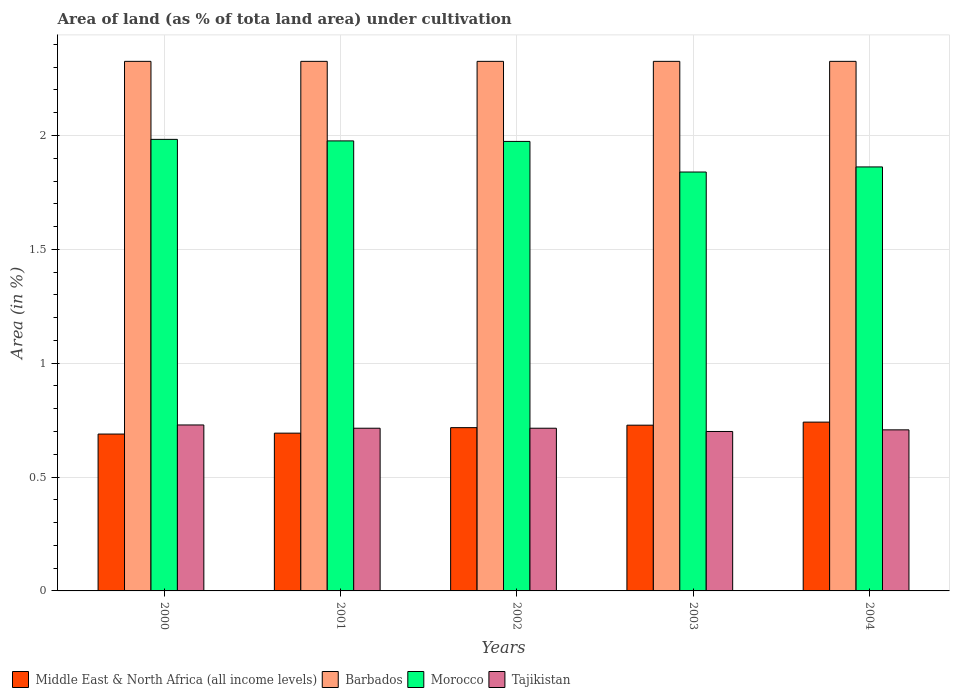Are the number of bars on each tick of the X-axis equal?
Ensure brevity in your answer.  Yes. How many bars are there on the 5th tick from the right?
Your answer should be compact. 4. What is the label of the 4th group of bars from the left?
Provide a succinct answer. 2003. What is the percentage of land under cultivation in Tajikistan in 2001?
Make the answer very short. 0.71. Across all years, what is the maximum percentage of land under cultivation in Morocco?
Make the answer very short. 1.98. Across all years, what is the minimum percentage of land under cultivation in Tajikistan?
Keep it short and to the point. 0.7. In which year was the percentage of land under cultivation in Middle East & North Africa (all income levels) minimum?
Provide a short and direct response. 2000. What is the total percentage of land under cultivation in Barbados in the graph?
Ensure brevity in your answer.  11.63. What is the difference between the percentage of land under cultivation in Tajikistan in 2001 and the percentage of land under cultivation in Barbados in 2002?
Your response must be concise. -1.61. What is the average percentage of land under cultivation in Middle East & North Africa (all income levels) per year?
Provide a succinct answer. 0.71. In the year 2000, what is the difference between the percentage of land under cultivation in Morocco and percentage of land under cultivation in Barbados?
Your answer should be compact. -0.34. What is the difference between the highest and the second highest percentage of land under cultivation in Tajikistan?
Offer a terse response. 0.01. What is the difference between the highest and the lowest percentage of land under cultivation in Morocco?
Your answer should be very brief. 0.14. Is the sum of the percentage of land under cultivation in Morocco in 2001 and 2002 greater than the maximum percentage of land under cultivation in Middle East & North Africa (all income levels) across all years?
Provide a succinct answer. Yes. Is it the case that in every year, the sum of the percentage of land under cultivation in Tajikistan and percentage of land under cultivation in Middle East & North Africa (all income levels) is greater than the sum of percentage of land under cultivation in Barbados and percentage of land under cultivation in Morocco?
Provide a succinct answer. No. What does the 3rd bar from the left in 2000 represents?
Your answer should be very brief. Morocco. What does the 4th bar from the right in 2000 represents?
Offer a very short reply. Middle East & North Africa (all income levels). Is it the case that in every year, the sum of the percentage of land under cultivation in Tajikistan and percentage of land under cultivation in Barbados is greater than the percentage of land under cultivation in Morocco?
Offer a very short reply. Yes. What is the difference between two consecutive major ticks on the Y-axis?
Your answer should be very brief. 0.5. Are the values on the major ticks of Y-axis written in scientific E-notation?
Provide a short and direct response. No. Where does the legend appear in the graph?
Provide a short and direct response. Bottom left. How many legend labels are there?
Provide a succinct answer. 4. What is the title of the graph?
Offer a terse response. Area of land (as % of tota land area) under cultivation. What is the label or title of the X-axis?
Your response must be concise. Years. What is the label or title of the Y-axis?
Keep it short and to the point. Area (in %). What is the Area (in %) of Middle East & North Africa (all income levels) in 2000?
Give a very brief answer. 0.69. What is the Area (in %) of Barbados in 2000?
Your answer should be very brief. 2.33. What is the Area (in %) in Morocco in 2000?
Offer a very short reply. 1.98. What is the Area (in %) of Tajikistan in 2000?
Your response must be concise. 0.73. What is the Area (in %) of Middle East & North Africa (all income levels) in 2001?
Provide a short and direct response. 0.69. What is the Area (in %) in Barbados in 2001?
Ensure brevity in your answer.  2.33. What is the Area (in %) in Morocco in 2001?
Your answer should be very brief. 1.98. What is the Area (in %) in Tajikistan in 2001?
Keep it short and to the point. 0.71. What is the Area (in %) of Middle East & North Africa (all income levels) in 2002?
Your response must be concise. 0.72. What is the Area (in %) of Barbados in 2002?
Provide a succinct answer. 2.33. What is the Area (in %) of Morocco in 2002?
Provide a succinct answer. 1.97. What is the Area (in %) in Tajikistan in 2002?
Offer a very short reply. 0.71. What is the Area (in %) in Middle East & North Africa (all income levels) in 2003?
Offer a terse response. 0.73. What is the Area (in %) in Barbados in 2003?
Your response must be concise. 2.33. What is the Area (in %) in Morocco in 2003?
Ensure brevity in your answer.  1.84. What is the Area (in %) of Tajikistan in 2003?
Keep it short and to the point. 0.7. What is the Area (in %) of Middle East & North Africa (all income levels) in 2004?
Your response must be concise. 0.74. What is the Area (in %) of Barbados in 2004?
Provide a short and direct response. 2.33. What is the Area (in %) in Morocco in 2004?
Keep it short and to the point. 1.86. What is the Area (in %) in Tajikistan in 2004?
Ensure brevity in your answer.  0.71. Across all years, what is the maximum Area (in %) in Middle East & North Africa (all income levels)?
Provide a succinct answer. 0.74. Across all years, what is the maximum Area (in %) of Barbados?
Give a very brief answer. 2.33. Across all years, what is the maximum Area (in %) of Morocco?
Your answer should be compact. 1.98. Across all years, what is the maximum Area (in %) in Tajikistan?
Ensure brevity in your answer.  0.73. Across all years, what is the minimum Area (in %) in Middle East & North Africa (all income levels)?
Ensure brevity in your answer.  0.69. Across all years, what is the minimum Area (in %) in Barbados?
Give a very brief answer. 2.33. Across all years, what is the minimum Area (in %) in Morocco?
Provide a succinct answer. 1.84. Across all years, what is the minimum Area (in %) in Tajikistan?
Offer a very short reply. 0.7. What is the total Area (in %) in Middle East & North Africa (all income levels) in the graph?
Provide a succinct answer. 3.57. What is the total Area (in %) of Barbados in the graph?
Keep it short and to the point. 11.63. What is the total Area (in %) of Morocco in the graph?
Ensure brevity in your answer.  9.63. What is the total Area (in %) of Tajikistan in the graph?
Ensure brevity in your answer.  3.57. What is the difference between the Area (in %) in Middle East & North Africa (all income levels) in 2000 and that in 2001?
Your answer should be compact. -0. What is the difference between the Area (in %) of Barbados in 2000 and that in 2001?
Your answer should be compact. 0. What is the difference between the Area (in %) of Morocco in 2000 and that in 2001?
Offer a very short reply. 0.01. What is the difference between the Area (in %) in Tajikistan in 2000 and that in 2001?
Offer a very short reply. 0.01. What is the difference between the Area (in %) of Middle East & North Africa (all income levels) in 2000 and that in 2002?
Ensure brevity in your answer.  -0.03. What is the difference between the Area (in %) in Barbados in 2000 and that in 2002?
Your answer should be compact. 0. What is the difference between the Area (in %) in Morocco in 2000 and that in 2002?
Provide a short and direct response. 0.01. What is the difference between the Area (in %) of Tajikistan in 2000 and that in 2002?
Offer a very short reply. 0.01. What is the difference between the Area (in %) in Middle East & North Africa (all income levels) in 2000 and that in 2003?
Provide a short and direct response. -0.04. What is the difference between the Area (in %) of Barbados in 2000 and that in 2003?
Keep it short and to the point. 0. What is the difference between the Area (in %) of Morocco in 2000 and that in 2003?
Provide a short and direct response. 0.14. What is the difference between the Area (in %) of Tajikistan in 2000 and that in 2003?
Your response must be concise. 0.03. What is the difference between the Area (in %) of Middle East & North Africa (all income levels) in 2000 and that in 2004?
Your response must be concise. -0.05. What is the difference between the Area (in %) of Morocco in 2000 and that in 2004?
Your response must be concise. 0.12. What is the difference between the Area (in %) of Tajikistan in 2000 and that in 2004?
Your answer should be compact. 0.02. What is the difference between the Area (in %) of Middle East & North Africa (all income levels) in 2001 and that in 2002?
Provide a short and direct response. -0.02. What is the difference between the Area (in %) in Morocco in 2001 and that in 2002?
Keep it short and to the point. 0. What is the difference between the Area (in %) of Middle East & North Africa (all income levels) in 2001 and that in 2003?
Make the answer very short. -0.04. What is the difference between the Area (in %) of Barbados in 2001 and that in 2003?
Offer a terse response. 0. What is the difference between the Area (in %) of Morocco in 2001 and that in 2003?
Your response must be concise. 0.14. What is the difference between the Area (in %) of Tajikistan in 2001 and that in 2003?
Offer a very short reply. 0.01. What is the difference between the Area (in %) of Middle East & North Africa (all income levels) in 2001 and that in 2004?
Make the answer very short. -0.05. What is the difference between the Area (in %) in Barbados in 2001 and that in 2004?
Provide a succinct answer. 0. What is the difference between the Area (in %) in Morocco in 2001 and that in 2004?
Provide a short and direct response. 0.11. What is the difference between the Area (in %) of Tajikistan in 2001 and that in 2004?
Ensure brevity in your answer.  0.01. What is the difference between the Area (in %) in Middle East & North Africa (all income levels) in 2002 and that in 2003?
Ensure brevity in your answer.  -0.01. What is the difference between the Area (in %) of Morocco in 2002 and that in 2003?
Provide a succinct answer. 0.13. What is the difference between the Area (in %) in Tajikistan in 2002 and that in 2003?
Provide a short and direct response. 0.01. What is the difference between the Area (in %) in Middle East & North Africa (all income levels) in 2002 and that in 2004?
Provide a succinct answer. -0.02. What is the difference between the Area (in %) in Morocco in 2002 and that in 2004?
Your answer should be very brief. 0.11. What is the difference between the Area (in %) in Tajikistan in 2002 and that in 2004?
Keep it short and to the point. 0.01. What is the difference between the Area (in %) in Middle East & North Africa (all income levels) in 2003 and that in 2004?
Provide a succinct answer. -0.01. What is the difference between the Area (in %) of Morocco in 2003 and that in 2004?
Your answer should be compact. -0.02. What is the difference between the Area (in %) of Tajikistan in 2003 and that in 2004?
Keep it short and to the point. -0.01. What is the difference between the Area (in %) in Middle East & North Africa (all income levels) in 2000 and the Area (in %) in Barbados in 2001?
Offer a very short reply. -1.64. What is the difference between the Area (in %) of Middle East & North Africa (all income levels) in 2000 and the Area (in %) of Morocco in 2001?
Provide a short and direct response. -1.29. What is the difference between the Area (in %) in Middle East & North Africa (all income levels) in 2000 and the Area (in %) in Tajikistan in 2001?
Offer a terse response. -0.03. What is the difference between the Area (in %) of Barbados in 2000 and the Area (in %) of Morocco in 2001?
Your response must be concise. 0.35. What is the difference between the Area (in %) in Barbados in 2000 and the Area (in %) in Tajikistan in 2001?
Your answer should be compact. 1.61. What is the difference between the Area (in %) of Morocco in 2000 and the Area (in %) of Tajikistan in 2001?
Offer a very short reply. 1.27. What is the difference between the Area (in %) in Middle East & North Africa (all income levels) in 2000 and the Area (in %) in Barbados in 2002?
Ensure brevity in your answer.  -1.64. What is the difference between the Area (in %) of Middle East & North Africa (all income levels) in 2000 and the Area (in %) of Morocco in 2002?
Give a very brief answer. -1.29. What is the difference between the Area (in %) in Middle East & North Africa (all income levels) in 2000 and the Area (in %) in Tajikistan in 2002?
Provide a succinct answer. -0.03. What is the difference between the Area (in %) of Barbados in 2000 and the Area (in %) of Morocco in 2002?
Offer a very short reply. 0.35. What is the difference between the Area (in %) of Barbados in 2000 and the Area (in %) of Tajikistan in 2002?
Make the answer very short. 1.61. What is the difference between the Area (in %) of Morocco in 2000 and the Area (in %) of Tajikistan in 2002?
Provide a short and direct response. 1.27. What is the difference between the Area (in %) in Middle East & North Africa (all income levels) in 2000 and the Area (in %) in Barbados in 2003?
Ensure brevity in your answer.  -1.64. What is the difference between the Area (in %) in Middle East & North Africa (all income levels) in 2000 and the Area (in %) in Morocco in 2003?
Provide a succinct answer. -1.15. What is the difference between the Area (in %) in Middle East & North Africa (all income levels) in 2000 and the Area (in %) in Tajikistan in 2003?
Provide a succinct answer. -0.01. What is the difference between the Area (in %) of Barbados in 2000 and the Area (in %) of Morocco in 2003?
Provide a short and direct response. 0.49. What is the difference between the Area (in %) in Barbados in 2000 and the Area (in %) in Tajikistan in 2003?
Make the answer very short. 1.63. What is the difference between the Area (in %) in Morocco in 2000 and the Area (in %) in Tajikistan in 2003?
Provide a short and direct response. 1.28. What is the difference between the Area (in %) in Middle East & North Africa (all income levels) in 2000 and the Area (in %) in Barbados in 2004?
Make the answer very short. -1.64. What is the difference between the Area (in %) in Middle East & North Africa (all income levels) in 2000 and the Area (in %) in Morocco in 2004?
Your answer should be compact. -1.17. What is the difference between the Area (in %) in Middle East & North Africa (all income levels) in 2000 and the Area (in %) in Tajikistan in 2004?
Provide a succinct answer. -0.02. What is the difference between the Area (in %) in Barbados in 2000 and the Area (in %) in Morocco in 2004?
Your answer should be compact. 0.46. What is the difference between the Area (in %) of Barbados in 2000 and the Area (in %) of Tajikistan in 2004?
Provide a succinct answer. 1.62. What is the difference between the Area (in %) of Morocco in 2000 and the Area (in %) of Tajikistan in 2004?
Your answer should be very brief. 1.28. What is the difference between the Area (in %) of Middle East & North Africa (all income levels) in 2001 and the Area (in %) of Barbados in 2002?
Provide a succinct answer. -1.63. What is the difference between the Area (in %) in Middle East & North Africa (all income levels) in 2001 and the Area (in %) in Morocco in 2002?
Offer a very short reply. -1.28. What is the difference between the Area (in %) in Middle East & North Africa (all income levels) in 2001 and the Area (in %) in Tajikistan in 2002?
Your answer should be compact. -0.02. What is the difference between the Area (in %) of Barbados in 2001 and the Area (in %) of Morocco in 2002?
Ensure brevity in your answer.  0.35. What is the difference between the Area (in %) in Barbados in 2001 and the Area (in %) in Tajikistan in 2002?
Provide a short and direct response. 1.61. What is the difference between the Area (in %) in Morocco in 2001 and the Area (in %) in Tajikistan in 2002?
Your response must be concise. 1.26. What is the difference between the Area (in %) of Middle East & North Africa (all income levels) in 2001 and the Area (in %) of Barbados in 2003?
Make the answer very short. -1.63. What is the difference between the Area (in %) of Middle East & North Africa (all income levels) in 2001 and the Area (in %) of Morocco in 2003?
Keep it short and to the point. -1.15. What is the difference between the Area (in %) in Middle East & North Africa (all income levels) in 2001 and the Area (in %) in Tajikistan in 2003?
Keep it short and to the point. -0.01. What is the difference between the Area (in %) in Barbados in 2001 and the Area (in %) in Morocco in 2003?
Keep it short and to the point. 0.49. What is the difference between the Area (in %) in Barbados in 2001 and the Area (in %) in Tajikistan in 2003?
Keep it short and to the point. 1.63. What is the difference between the Area (in %) of Morocco in 2001 and the Area (in %) of Tajikistan in 2003?
Provide a succinct answer. 1.28. What is the difference between the Area (in %) in Middle East & North Africa (all income levels) in 2001 and the Area (in %) in Barbados in 2004?
Make the answer very short. -1.63. What is the difference between the Area (in %) in Middle East & North Africa (all income levels) in 2001 and the Area (in %) in Morocco in 2004?
Offer a very short reply. -1.17. What is the difference between the Area (in %) in Middle East & North Africa (all income levels) in 2001 and the Area (in %) in Tajikistan in 2004?
Provide a succinct answer. -0.01. What is the difference between the Area (in %) in Barbados in 2001 and the Area (in %) in Morocco in 2004?
Ensure brevity in your answer.  0.46. What is the difference between the Area (in %) in Barbados in 2001 and the Area (in %) in Tajikistan in 2004?
Make the answer very short. 1.62. What is the difference between the Area (in %) of Morocco in 2001 and the Area (in %) of Tajikistan in 2004?
Ensure brevity in your answer.  1.27. What is the difference between the Area (in %) of Middle East & North Africa (all income levels) in 2002 and the Area (in %) of Barbados in 2003?
Ensure brevity in your answer.  -1.61. What is the difference between the Area (in %) of Middle East & North Africa (all income levels) in 2002 and the Area (in %) of Morocco in 2003?
Ensure brevity in your answer.  -1.12. What is the difference between the Area (in %) of Middle East & North Africa (all income levels) in 2002 and the Area (in %) of Tajikistan in 2003?
Give a very brief answer. 0.02. What is the difference between the Area (in %) of Barbados in 2002 and the Area (in %) of Morocco in 2003?
Keep it short and to the point. 0.49. What is the difference between the Area (in %) in Barbados in 2002 and the Area (in %) in Tajikistan in 2003?
Offer a terse response. 1.63. What is the difference between the Area (in %) of Morocco in 2002 and the Area (in %) of Tajikistan in 2003?
Your answer should be compact. 1.27. What is the difference between the Area (in %) of Middle East & North Africa (all income levels) in 2002 and the Area (in %) of Barbados in 2004?
Offer a very short reply. -1.61. What is the difference between the Area (in %) of Middle East & North Africa (all income levels) in 2002 and the Area (in %) of Morocco in 2004?
Your answer should be compact. -1.15. What is the difference between the Area (in %) in Middle East & North Africa (all income levels) in 2002 and the Area (in %) in Tajikistan in 2004?
Ensure brevity in your answer.  0.01. What is the difference between the Area (in %) in Barbados in 2002 and the Area (in %) in Morocco in 2004?
Provide a short and direct response. 0.46. What is the difference between the Area (in %) of Barbados in 2002 and the Area (in %) of Tajikistan in 2004?
Provide a succinct answer. 1.62. What is the difference between the Area (in %) in Morocco in 2002 and the Area (in %) in Tajikistan in 2004?
Your answer should be compact. 1.27. What is the difference between the Area (in %) in Middle East & North Africa (all income levels) in 2003 and the Area (in %) in Barbados in 2004?
Keep it short and to the point. -1.6. What is the difference between the Area (in %) in Middle East & North Africa (all income levels) in 2003 and the Area (in %) in Morocco in 2004?
Your response must be concise. -1.13. What is the difference between the Area (in %) in Middle East & North Africa (all income levels) in 2003 and the Area (in %) in Tajikistan in 2004?
Make the answer very short. 0.02. What is the difference between the Area (in %) of Barbados in 2003 and the Area (in %) of Morocco in 2004?
Make the answer very short. 0.46. What is the difference between the Area (in %) of Barbados in 2003 and the Area (in %) of Tajikistan in 2004?
Your response must be concise. 1.62. What is the difference between the Area (in %) in Morocco in 2003 and the Area (in %) in Tajikistan in 2004?
Keep it short and to the point. 1.13. What is the average Area (in %) in Middle East & North Africa (all income levels) per year?
Provide a short and direct response. 0.71. What is the average Area (in %) in Barbados per year?
Your answer should be compact. 2.33. What is the average Area (in %) in Morocco per year?
Ensure brevity in your answer.  1.93. What is the average Area (in %) of Tajikistan per year?
Provide a succinct answer. 0.71. In the year 2000, what is the difference between the Area (in %) in Middle East & North Africa (all income levels) and Area (in %) in Barbados?
Give a very brief answer. -1.64. In the year 2000, what is the difference between the Area (in %) of Middle East & North Africa (all income levels) and Area (in %) of Morocco?
Give a very brief answer. -1.29. In the year 2000, what is the difference between the Area (in %) in Middle East & North Africa (all income levels) and Area (in %) in Tajikistan?
Provide a succinct answer. -0.04. In the year 2000, what is the difference between the Area (in %) in Barbados and Area (in %) in Morocco?
Keep it short and to the point. 0.34. In the year 2000, what is the difference between the Area (in %) of Barbados and Area (in %) of Tajikistan?
Ensure brevity in your answer.  1.6. In the year 2000, what is the difference between the Area (in %) of Morocco and Area (in %) of Tajikistan?
Your response must be concise. 1.25. In the year 2001, what is the difference between the Area (in %) in Middle East & North Africa (all income levels) and Area (in %) in Barbados?
Ensure brevity in your answer.  -1.63. In the year 2001, what is the difference between the Area (in %) of Middle East & North Africa (all income levels) and Area (in %) of Morocco?
Your response must be concise. -1.28. In the year 2001, what is the difference between the Area (in %) of Middle East & North Africa (all income levels) and Area (in %) of Tajikistan?
Make the answer very short. -0.02. In the year 2001, what is the difference between the Area (in %) of Barbados and Area (in %) of Morocco?
Keep it short and to the point. 0.35. In the year 2001, what is the difference between the Area (in %) in Barbados and Area (in %) in Tajikistan?
Keep it short and to the point. 1.61. In the year 2001, what is the difference between the Area (in %) in Morocco and Area (in %) in Tajikistan?
Give a very brief answer. 1.26. In the year 2002, what is the difference between the Area (in %) of Middle East & North Africa (all income levels) and Area (in %) of Barbados?
Offer a very short reply. -1.61. In the year 2002, what is the difference between the Area (in %) of Middle East & North Africa (all income levels) and Area (in %) of Morocco?
Offer a very short reply. -1.26. In the year 2002, what is the difference between the Area (in %) in Middle East & North Africa (all income levels) and Area (in %) in Tajikistan?
Offer a terse response. 0. In the year 2002, what is the difference between the Area (in %) of Barbados and Area (in %) of Morocco?
Your answer should be compact. 0.35. In the year 2002, what is the difference between the Area (in %) of Barbados and Area (in %) of Tajikistan?
Provide a short and direct response. 1.61. In the year 2002, what is the difference between the Area (in %) of Morocco and Area (in %) of Tajikistan?
Your answer should be compact. 1.26. In the year 2003, what is the difference between the Area (in %) in Middle East & North Africa (all income levels) and Area (in %) in Barbados?
Offer a terse response. -1.6. In the year 2003, what is the difference between the Area (in %) in Middle East & North Africa (all income levels) and Area (in %) in Morocco?
Offer a very short reply. -1.11. In the year 2003, what is the difference between the Area (in %) of Middle East & North Africa (all income levels) and Area (in %) of Tajikistan?
Keep it short and to the point. 0.03. In the year 2003, what is the difference between the Area (in %) in Barbados and Area (in %) in Morocco?
Offer a terse response. 0.49. In the year 2003, what is the difference between the Area (in %) of Barbados and Area (in %) of Tajikistan?
Make the answer very short. 1.63. In the year 2003, what is the difference between the Area (in %) of Morocco and Area (in %) of Tajikistan?
Provide a short and direct response. 1.14. In the year 2004, what is the difference between the Area (in %) in Middle East & North Africa (all income levels) and Area (in %) in Barbados?
Give a very brief answer. -1.58. In the year 2004, what is the difference between the Area (in %) of Middle East & North Africa (all income levels) and Area (in %) of Morocco?
Provide a short and direct response. -1.12. In the year 2004, what is the difference between the Area (in %) in Middle East & North Africa (all income levels) and Area (in %) in Tajikistan?
Make the answer very short. 0.03. In the year 2004, what is the difference between the Area (in %) in Barbados and Area (in %) in Morocco?
Keep it short and to the point. 0.46. In the year 2004, what is the difference between the Area (in %) in Barbados and Area (in %) in Tajikistan?
Offer a terse response. 1.62. In the year 2004, what is the difference between the Area (in %) in Morocco and Area (in %) in Tajikistan?
Offer a very short reply. 1.15. What is the ratio of the Area (in %) in Middle East & North Africa (all income levels) in 2000 to that in 2001?
Keep it short and to the point. 0.99. What is the ratio of the Area (in %) in Barbados in 2000 to that in 2001?
Make the answer very short. 1. What is the ratio of the Area (in %) in Tajikistan in 2000 to that in 2001?
Offer a terse response. 1.02. What is the ratio of the Area (in %) of Middle East & North Africa (all income levels) in 2000 to that in 2002?
Provide a succinct answer. 0.96. What is the ratio of the Area (in %) in Tajikistan in 2000 to that in 2002?
Make the answer very short. 1.02. What is the ratio of the Area (in %) in Middle East & North Africa (all income levels) in 2000 to that in 2003?
Your answer should be very brief. 0.95. What is the ratio of the Area (in %) in Barbados in 2000 to that in 2003?
Offer a very short reply. 1. What is the ratio of the Area (in %) in Morocco in 2000 to that in 2003?
Your answer should be very brief. 1.08. What is the ratio of the Area (in %) of Tajikistan in 2000 to that in 2003?
Provide a succinct answer. 1.04. What is the ratio of the Area (in %) in Middle East & North Africa (all income levels) in 2000 to that in 2004?
Offer a very short reply. 0.93. What is the ratio of the Area (in %) in Morocco in 2000 to that in 2004?
Give a very brief answer. 1.06. What is the ratio of the Area (in %) of Tajikistan in 2000 to that in 2004?
Your response must be concise. 1.03. What is the ratio of the Area (in %) of Middle East & North Africa (all income levels) in 2001 to that in 2002?
Provide a succinct answer. 0.97. What is the ratio of the Area (in %) of Barbados in 2001 to that in 2002?
Your answer should be compact. 1. What is the ratio of the Area (in %) in Morocco in 2001 to that in 2002?
Ensure brevity in your answer.  1. What is the ratio of the Area (in %) of Middle East & North Africa (all income levels) in 2001 to that in 2003?
Your answer should be very brief. 0.95. What is the ratio of the Area (in %) of Barbados in 2001 to that in 2003?
Provide a succinct answer. 1. What is the ratio of the Area (in %) of Morocco in 2001 to that in 2003?
Keep it short and to the point. 1.07. What is the ratio of the Area (in %) of Tajikistan in 2001 to that in 2003?
Your answer should be very brief. 1.02. What is the ratio of the Area (in %) in Middle East & North Africa (all income levels) in 2001 to that in 2004?
Your answer should be compact. 0.93. What is the ratio of the Area (in %) of Morocco in 2001 to that in 2004?
Ensure brevity in your answer.  1.06. What is the ratio of the Area (in %) in Middle East & North Africa (all income levels) in 2002 to that in 2003?
Offer a very short reply. 0.99. What is the ratio of the Area (in %) of Barbados in 2002 to that in 2003?
Your response must be concise. 1. What is the ratio of the Area (in %) in Morocco in 2002 to that in 2003?
Ensure brevity in your answer.  1.07. What is the ratio of the Area (in %) of Tajikistan in 2002 to that in 2003?
Your answer should be very brief. 1.02. What is the ratio of the Area (in %) in Middle East & North Africa (all income levels) in 2002 to that in 2004?
Your answer should be very brief. 0.97. What is the ratio of the Area (in %) of Morocco in 2002 to that in 2004?
Make the answer very short. 1.06. What is the ratio of the Area (in %) in Tajikistan in 2002 to that in 2004?
Ensure brevity in your answer.  1.01. What is the ratio of the Area (in %) in Middle East & North Africa (all income levels) in 2003 to that in 2004?
Your response must be concise. 0.98. What is the ratio of the Area (in %) of Barbados in 2003 to that in 2004?
Provide a short and direct response. 1. What is the ratio of the Area (in %) in Morocco in 2003 to that in 2004?
Give a very brief answer. 0.99. What is the ratio of the Area (in %) of Tajikistan in 2003 to that in 2004?
Ensure brevity in your answer.  0.99. What is the difference between the highest and the second highest Area (in %) in Middle East & North Africa (all income levels)?
Keep it short and to the point. 0.01. What is the difference between the highest and the second highest Area (in %) of Barbados?
Provide a short and direct response. 0. What is the difference between the highest and the second highest Area (in %) in Morocco?
Your answer should be compact. 0.01. What is the difference between the highest and the second highest Area (in %) in Tajikistan?
Your response must be concise. 0.01. What is the difference between the highest and the lowest Area (in %) of Middle East & North Africa (all income levels)?
Give a very brief answer. 0.05. What is the difference between the highest and the lowest Area (in %) of Morocco?
Your answer should be compact. 0.14. What is the difference between the highest and the lowest Area (in %) of Tajikistan?
Offer a terse response. 0.03. 